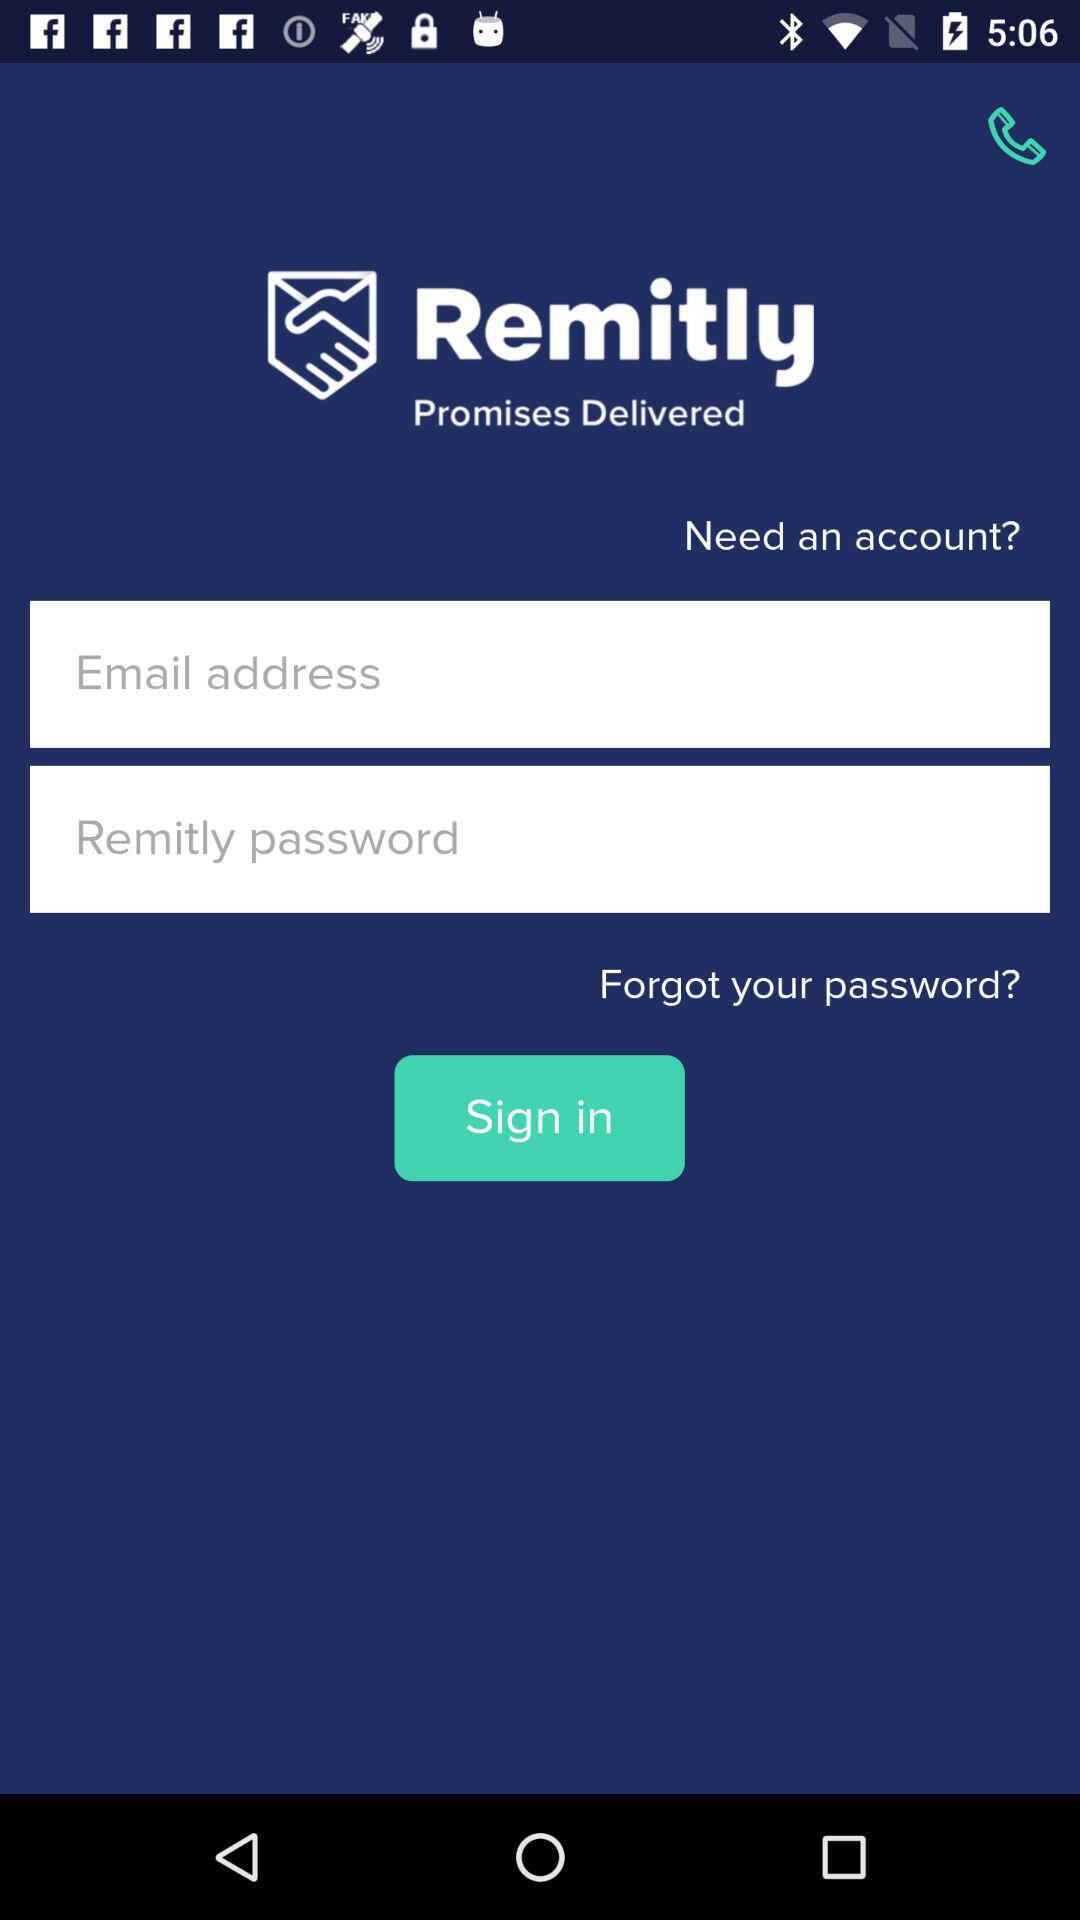What is the app name? The app name is "Remitly". 